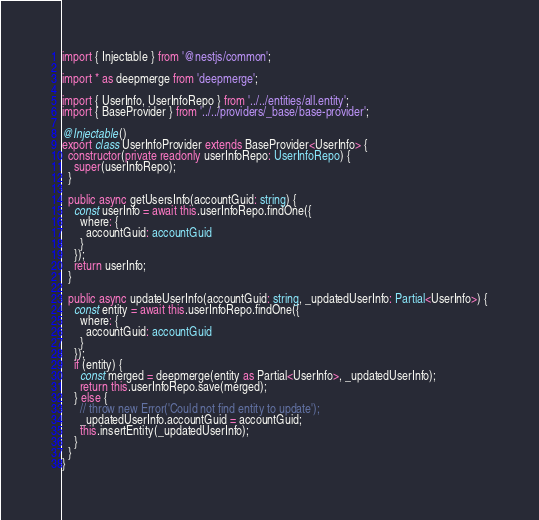<code> <loc_0><loc_0><loc_500><loc_500><_TypeScript_>import { Injectable } from '@nestjs/common';

import * as deepmerge from 'deepmerge';

import { UserInfo, UserInfoRepo } from '../../entities/all.entity';
import { BaseProvider } from '../../providers/_base/base-provider';

@Injectable()
export class UserInfoProvider extends BaseProvider<UserInfo> {
  constructor(private readonly userInfoRepo: UserInfoRepo) {
    super(userInfoRepo);
  }

  public async getUsersInfo(accountGuid: string) {
    const userInfo = await this.userInfoRepo.findOne({
      where: {
        accountGuid: accountGuid
      }
    });
    return userInfo;
  }

  public async updateUserInfo(accountGuid: string, _updatedUserInfo: Partial<UserInfo>) {
    const entity = await this.userInfoRepo.findOne({
      where: {
        accountGuid: accountGuid
      }
    });
    if (entity) {
      const merged = deepmerge(entity as Partial<UserInfo>, _updatedUserInfo);
      return this.userInfoRepo.save(merged);
    } else {
      // throw new Error('Could not find entity to update');
      _updatedUserInfo.accountGuid = accountGuid;
      this.insertEntity(_updatedUserInfo);
    }
  }
}
</code> 